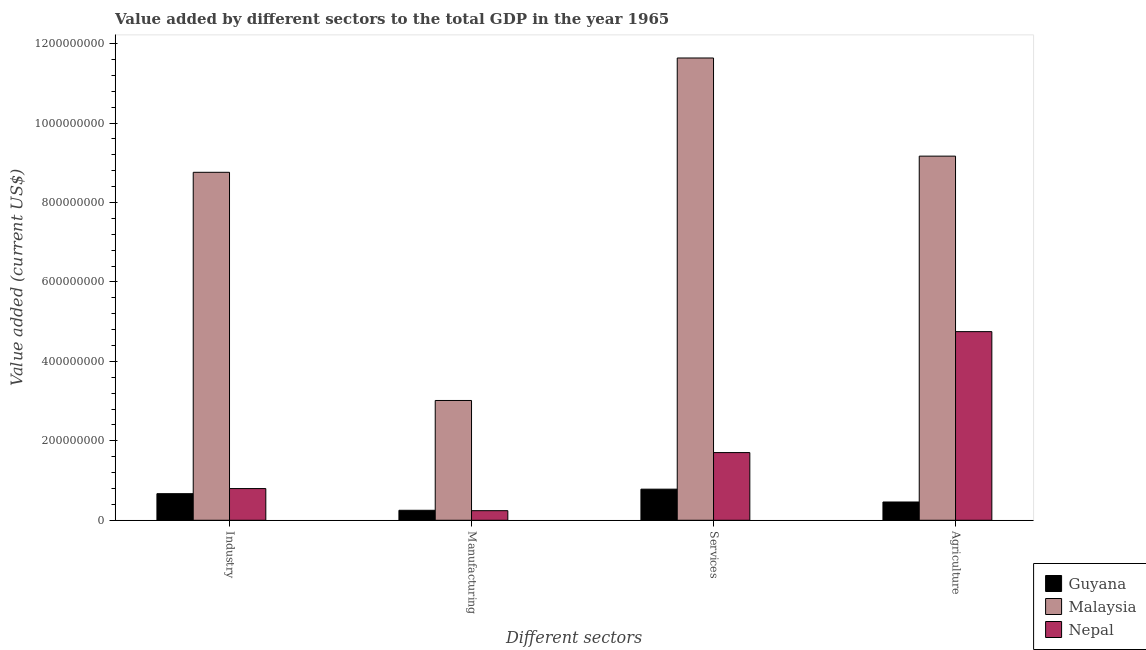How many different coloured bars are there?
Your response must be concise. 3. Are the number of bars per tick equal to the number of legend labels?
Provide a short and direct response. Yes. How many bars are there on the 2nd tick from the left?
Provide a short and direct response. 3. How many bars are there on the 4th tick from the right?
Make the answer very short. 3. What is the label of the 1st group of bars from the left?
Keep it short and to the point. Industry. What is the value added by services sector in Nepal?
Offer a terse response. 1.70e+08. Across all countries, what is the maximum value added by agricultural sector?
Provide a short and direct response. 9.17e+08. Across all countries, what is the minimum value added by agricultural sector?
Ensure brevity in your answer.  4.60e+07. In which country was the value added by industrial sector maximum?
Your answer should be compact. Malaysia. In which country was the value added by services sector minimum?
Offer a terse response. Guyana. What is the total value added by industrial sector in the graph?
Provide a short and direct response. 1.02e+09. What is the difference between the value added by industrial sector in Nepal and that in Malaysia?
Offer a terse response. -7.96e+08. What is the difference between the value added by industrial sector in Guyana and the value added by services sector in Nepal?
Give a very brief answer. -1.03e+08. What is the average value added by industrial sector per country?
Offer a terse response. 3.41e+08. What is the difference between the value added by services sector and value added by industrial sector in Malaysia?
Provide a short and direct response. 2.88e+08. In how many countries, is the value added by industrial sector greater than 360000000 US$?
Ensure brevity in your answer.  1. What is the ratio of the value added by services sector in Nepal to that in Guyana?
Offer a very short reply. 2.18. Is the value added by services sector in Nepal less than that in Malaysia?
Your response must be concise. Yes. What is the difference between the highest and the second highest value added by services sector?
Your answer should be compact. 9.93e+08. What is the difference between the highest and the lowest value added by services sector?
Provide a succinct answer. 1.09e+09. In how many countries, is the value added by services sector greater than the average value added by services sector taken over all countries?
Offer a very short reply. 1. Is the sum of the value added by industrial sector in Malaysia and Guyana greater than the maximum value added by agricultural sector across all countries?
Make the answer very short. Yes. What does the 3rd bar from the left in Agriculture represents?
Keep it short and to the point. Nepal. What does the 1st bar from the right in Services represents?
Ensure brevity in your answer.  Nepal. How many bars are there?
Keep it short and to the point. 12. How many countries are there in the graph?
Provide a succinct answer. 3. How many legend labels are there?
Ensure brevity in your answer.  3. How are the legend labels stacked?
Make the answer very short. Vertical. What is the title of the graph?
Offer a very short reply. Value added by different sectors to the total GDP in the year 1965. Does "Hong Kong" appear as one of the legend labels in the graph?
Make the answer very short. No. What is the label or title of the X-axis?
Offer a terse response. Different sectors. What is the label or title of the Y-axis?
Offer a very short reply. Value added (current US$). What is the Value added (current US$) in Guyana in Industry?
Offer a very short reply. 6.69e+07. What is the Value added (current US$) of Malaysia in Industry?
Ensure brevity in your answer.  8.76e+08. What is the Value added (current US$) of Nepal in Industry?
Your answer should be very brief. 7.98e+07. What is the Value added (current US$) in Guyana in Manufacturing?
Give a very brief answer. 2.51e+07. What is the Value added (current US$) of Malaysia in Manufacturing?
Your response must be concise. 3.02e+08. What is the Value added (current US$) of Nepal in Manufacturing?
Ensure brevity in your answer.  2.42e+07. What is the Value added (current US$) of Guyana in Services?
Provide a succinct answer. 7.83e+07. What is the Value added (current US$) of Malaysia in Services?
Give a very brief answer. 1.16e+09. What is the Value added (current US$) in Nepal in Services?
Offer a terse response. 1.70e+08. What is the Value added (current US$) in Guyana in Agriculture?
Offer a terse response. 4.60e+07. What is the Value added (current US$) in Malaysia in Agriculture?
Provide a succinct answer. 9.17e+08. What is the Value added (current US$) of Nepal in Agriculture?
Your answer should be very brief. 4.75e+08. Across all Different sectors, what is the maximum Value added (current US$) in Guyana?
Provide a succinct answer. 7.83e+07. Across all Different sectors, what is the maximum Value added (current US$) in Malaysia?
Offer a terse response. 1.16e+09. Across all Different sectors, what is the maximum Value added (current US$) in Nepal?
Offer a very short reply. 4.75e+08. Across all Different sectors, what is the minimum Value added (current US$) in Guyana?
Your answer should be compact. 2.51e+07. Across all Different sectors, what is the minimum Value added (current US$) of Malaysia?
Offer a terse response. 3.02e+08. Across all Different sectors, what is the minimum Value added (current US$) of Nepal?
Your answer should be compact. 2.42e+07. What is the total Value added (current US$) of Guyana in the graph?
Your answer should be compact. 2.16e+08. What is the total Value added (current US$) in Malaysia in the graph?
Your response must be concise. 3.26e+09. What is the total Value added (current US$) in Nepal in the graph?
Make the answer very short. 7.49e+08. What is the difference between the Value added (current US$) of Guyana in Industry and that in Manufacturing?
Keep it short and to the point. 4.18e+07. What is the difference between the Value added (current US$) of Malaysia in Industry and that in Manufacturing?
Offer a very short reply. 5.74e+08. What is the difference between the Value added (current US$) of Nepal in Industry and that in Manufacturing?
Offer a terse response. 5.57e+07. What is the difference between the Value added (current US$) in Guyana in Industry and that in Services?
Ensure brevity in your answer.  -1.14e+07. What is the difference between the Value added (current US$) of Malaysia in Industry and that in Services?
Ensure brevity in your answer.  -2.88e+08. What is the difference between the Value added (current US$) of Nepal in Industry and that in Services?
Your answer should be compact. -9.06e+07. What is the difference between the Value added (current US$) of Guyana in Industry and that in Agriculture?
Give a very brief answer. 2.09e+07. What is the difference between the Value added (current US$) in Malaysia in Industry and that in Agriculture?
Keep it short and to the point. -4.07e+07. What is the difference between the Value added (current US$) of Nepal in Industry and that in Agriculture?
Provide a succinct answer. -3.95e+08. What is the difference between the Value added (current US$) of Guyana in Manufacturing and that in Services?
Your answer should be very brief. -5.32e+07. What is the difference between the Value added (current US$) in Malaysia in Manufacturing and that in Services?
Offer a very short reply. -8.62e+08. What is the difference between the Value added (current US$) in Nepal in Manufacturing and that in Services?
Provide a short and direct response. -1.46e+08. What is the difference between the Value added (current US$) in Guyana in Manufacturing and that in Agriculture?
Your response must be concise. -2.09e+07. What is the difference between the Value added (current US$) of Malaysia in Manufacturing and that in Agriculture?
Provide a succinct answer. -6.15e+08. What is the difference between the Value added (current US$) of Nepal in Manufacturing and that in Agriculture?
Provide a succinct answer. -4.51e+08. What is the difference between the Value added (current US$) in Guyana in Services and that in Agriculture?
Your response must be concise. 3.23e+07. What is the difference between the Value added (current US$) in Malaysia in Services and that in Agriculture?
Your answer should be compact. 2.47e+08. What is the difference between the Value added (current US$) in Nepal in Services and that in Agriculture?
Your response must be concise. -3.05e+08. What is the difference between the Value added (current US$) of Guyana in Industry and the Value added (current US$) of Malaysia in Manufacturing?
Offer a very short reply. -2.35e+08. What is the difference between the Value added (current US$) of Guyana in Industry and the Value added (current US$) of Nepal in Manufacturing?
Ensure brevity in your answer.  4.28e+07. What is the difference between the Value added (current US$) in Malaysia in Industry and the Value added (current US$) in Nepal in Manufacturing?
Provide a succinct answer. 8.52e+08. What is the difference between the Value added (current US$) of Guyana in Industry and the Value added (current US$) of Malaysia in Services?
Make the answer very short. -1.10e+09. What is the difference between the Value added (current US$) of Guyana in Industry and the Value added (current US$) of Nepal in Services?
Your answer should be very brief. -1.03e+08. What is the difference between the Value added (current US$) in Malaysia in Industry and the Value added (current US$) in Nepal in Services?
Make the answer very short. 7.06e+08. What is the difference between the Value added (current US$) of Guyana in Industry and the Value added (current US$) of Malaysia in Agriculture?
Your answer should be compact. -8.50e+08. What is the difference between the Value added (current US$) of Guyana in Industry and the Value added (current US$) of Nepal in Agriculture?
Provide a succinct answer. -4.08e+08. What is the difference between the Value added (current US$) of Malaysia in Industry and the Value added (current US$) of Nepal in Agriculture?
Offer a terse response. 4.01e+08. What is the difference between the Value added (current US$) in Guyana in Manufacturing and the Value added (current US$) in Malaysia in Services?
Provide a succinct answer. -1.14e+09. What is the difference between the Value added (current US$) of Guyana in Manufacturing and the Value added (current US$) of Nepal in Services?
Provide a succinct answer. -1.45e+08. What is the difference between the Value added (current US$) in Malaysia in Manufacturing and the Value added (current US$) in Nepal in Services?
Your response must be concise. 1.31e+08. What is the difference between the Value added (current US$) of Guyana in Manufacturing and the Value added (current US$) of Malaysia in Agriculture?
Make the answer very short. -8.92e+08. What is the difference between the Value added (current US$) in Guyana in Manufacturing and the Value added (current US$) in Nepal in Agriculture?
Provide a succinct answer. -4.50e+08. What is the difference between the Value added (current US$) in Malaysia in Manufacturing and the Value added (current US$) in Nepal in Agriculture?
Keep it short and to the point. -1.73e+08. What is the difference between the Value added (current US$) in Guyana in Services and the Value added (current US$) in Malaysia in Agriculture?
Keep it short and to the point. -8.38e+08. What is the difference between the Value added (current US$) of Guyana in Services and the Value added (current US$) of Nepal in Agriculture?
Ensure brevity in your answer.  -3.97e+08. What is the difference between the Value added (current US$) of Malaysia in Services and the Value added (current US$) of Nepal in Agriculture?
Your answer should be very brief. 6.89e+08. What is the average Value added (current US$) of Guyana per Different sectors?
Keep it short and to the point. 5.41e+07. What is the average Value added (current US$) of Malaysia per Different sectors?
Your answer should be very brief. 8.14e+08. What is the average Value added (current US$) of Nepal per Different sectors?
Keep it short and to the point. 1.87e+08. What is the difference between the Value added (current US$) of Guyana and Value added (current US$) of Malaysia in Industry?
Your response must be concise. -8.09e+08. What is the difference between the Value added (current US$) of Guyana and Value added (current US$) of Nepal in Industry?
Your response must be concise. -1.29e+07. What is the difference between the Value added (current US$) of Malaysia and Value added (current US$) of Nepal in Industry?
Ensure brevity in your answer.  7.96e+08. What is the difference between the Value added (current US$) in Guyana and Value added (current US$) in Malaysia in Manufacturing?
Offer a very short reply. -2.76e+08. What is the difference between the Value added (current US$) of Guyana and Value added (current US$) of Nepal in Manufacturing?
Keep it short and to the point. 9.67e+05. What is the difference between the Value added (current US$) of Malaysia and Value added (current US$) of Nepal in Manufacturing?
Make the answer very short. 2.77e+08. What is the difference between the Value added (current US$) of Guyana and Value added (current US$) of Malaysia in Services?
Ensure brevity in your answer.  -1.09e+09. What is the difference between the Value added (current US$) of Guyana and Value added (current US$) of Nepal in Services?
Your answer should be compact. -9.21e+07. What is the difference between the Value added (current US$) in Malaysia and Value added (current US$) in Nepal in Services?
Provide a succinct answer. 9.93e+08. What is the difference between the Value added (current US$) in Guyana and Value added (current US$) in Malaysia in Agriculture?
Your answer should be compact. -8.71e+08. What is the difference between the Value added (current US$) of Guyana and Value added (current US$) of Nepal in Agriculture?
Provide a short and direct response. -4.29e+08. What is the difference between the Value added (current US$) of Malaysia and Value added (current US$) of Nepal in Agriculture?
Ensure brevity in your answer.  4.42e+08. What is the ratio of the Value added (current US$) of Guyana in Industry to that in Manufacturing?
Give a very brief answer. 2.67. What is the ratio of the Value added (current US$) in Malaysia in Industry to that in Manufacturing?
Your response must be concise. 2.9. What is the ratio of the Value added (current US$) of Nepal in Industry to that in Manufacturing?
Give a very brief answer. 3.3. What is the ratio of the Value added (current US$) of Guyana in Industry to that in Services?
Your answer should be very brief. 0.85. What is the ratio of the Value added (current US$) in Malaysia in Industry to that in Services?
Your answer should be compact. 0.75. What is the ratio of the Value added (current US$) of Nepal in Industry to that in Services?
Provide a short and direct response. 0.47. What is the ratio of the Value added (current US$) of Guyana in Industry to that in Agriculture?
Your response must be concise. 1.46. What is the ratio of the Value added (current US$) of Malaysia in Industry to that in Agriculture?
Provide a succinct answer. 0.96. What is the ratio of the Value added (current US$) of Nepal in Industry to that in Agriculture?
Keep it short and to the point. 0.17. What is the ratio of the Value added (current US$) in Guyana in Manufacturing to that in Services?
Provide a succinct answer. 0.32. What is the ratio of the Value added (current US$) in Malaysia in Manufacturing to that in Services?
Your response must be concise. 0.26. What is the ratio of the Value added (current US$) of Nepal in Manufacturing to that in Services?
Provide a succinct answer. 0.14. What is the ratio of the Value added (current US$) of Guyana in Manufacturing to that in Agriculture?
Your answer should be compact. 0.55. What is the ratio of the Value added (current US$) in Malaysia in Manufacturing to that in Agriculture?
Keep it short and to the point. 0.33. What is the ratio of the Value added (current US$) of Nepal in Manufacturing to that in Agriculture?
Your response must be concise. 0.05. What is the ratio of the Value added (current US$) in Guyana in Services to that in Agriculture?
Make the answer very short. 1.7. What is the ratio of the Value added (current US$) in Malaysia in Services to that in Agriculture?
Give a very brief answer. 1.27. What is the ratio of the Value added (current US$) of Nepal in Services to that in Agriculture?
Keep it short and to the point. 0.36. What is the difference between the highest and the second highest Value added (current US$) in Guyana?
Your answer should be compact. 1.14e+07. What is the difference between the highest and the second highest Value added (current US$) of Malaysia?
Provide a succinct answer. 2.47e+08. What is the difference between the highest and the second highest Value added (current US$) in Nepal?
Your response must be concise. 3.05e+08. What is the difference between the highest and the lowest Value added (current US$) in Guyana?
Give a very brief answer. 5.32e+07. What is the difference between the highest and the lowest Value added (current US$) of Malaysia?
Your response must be concise. 8.62e+08. What is the difference between the highest and the lowest Value added (current US$) in Nepal?
Offer a terse response. 4.51e+08. 